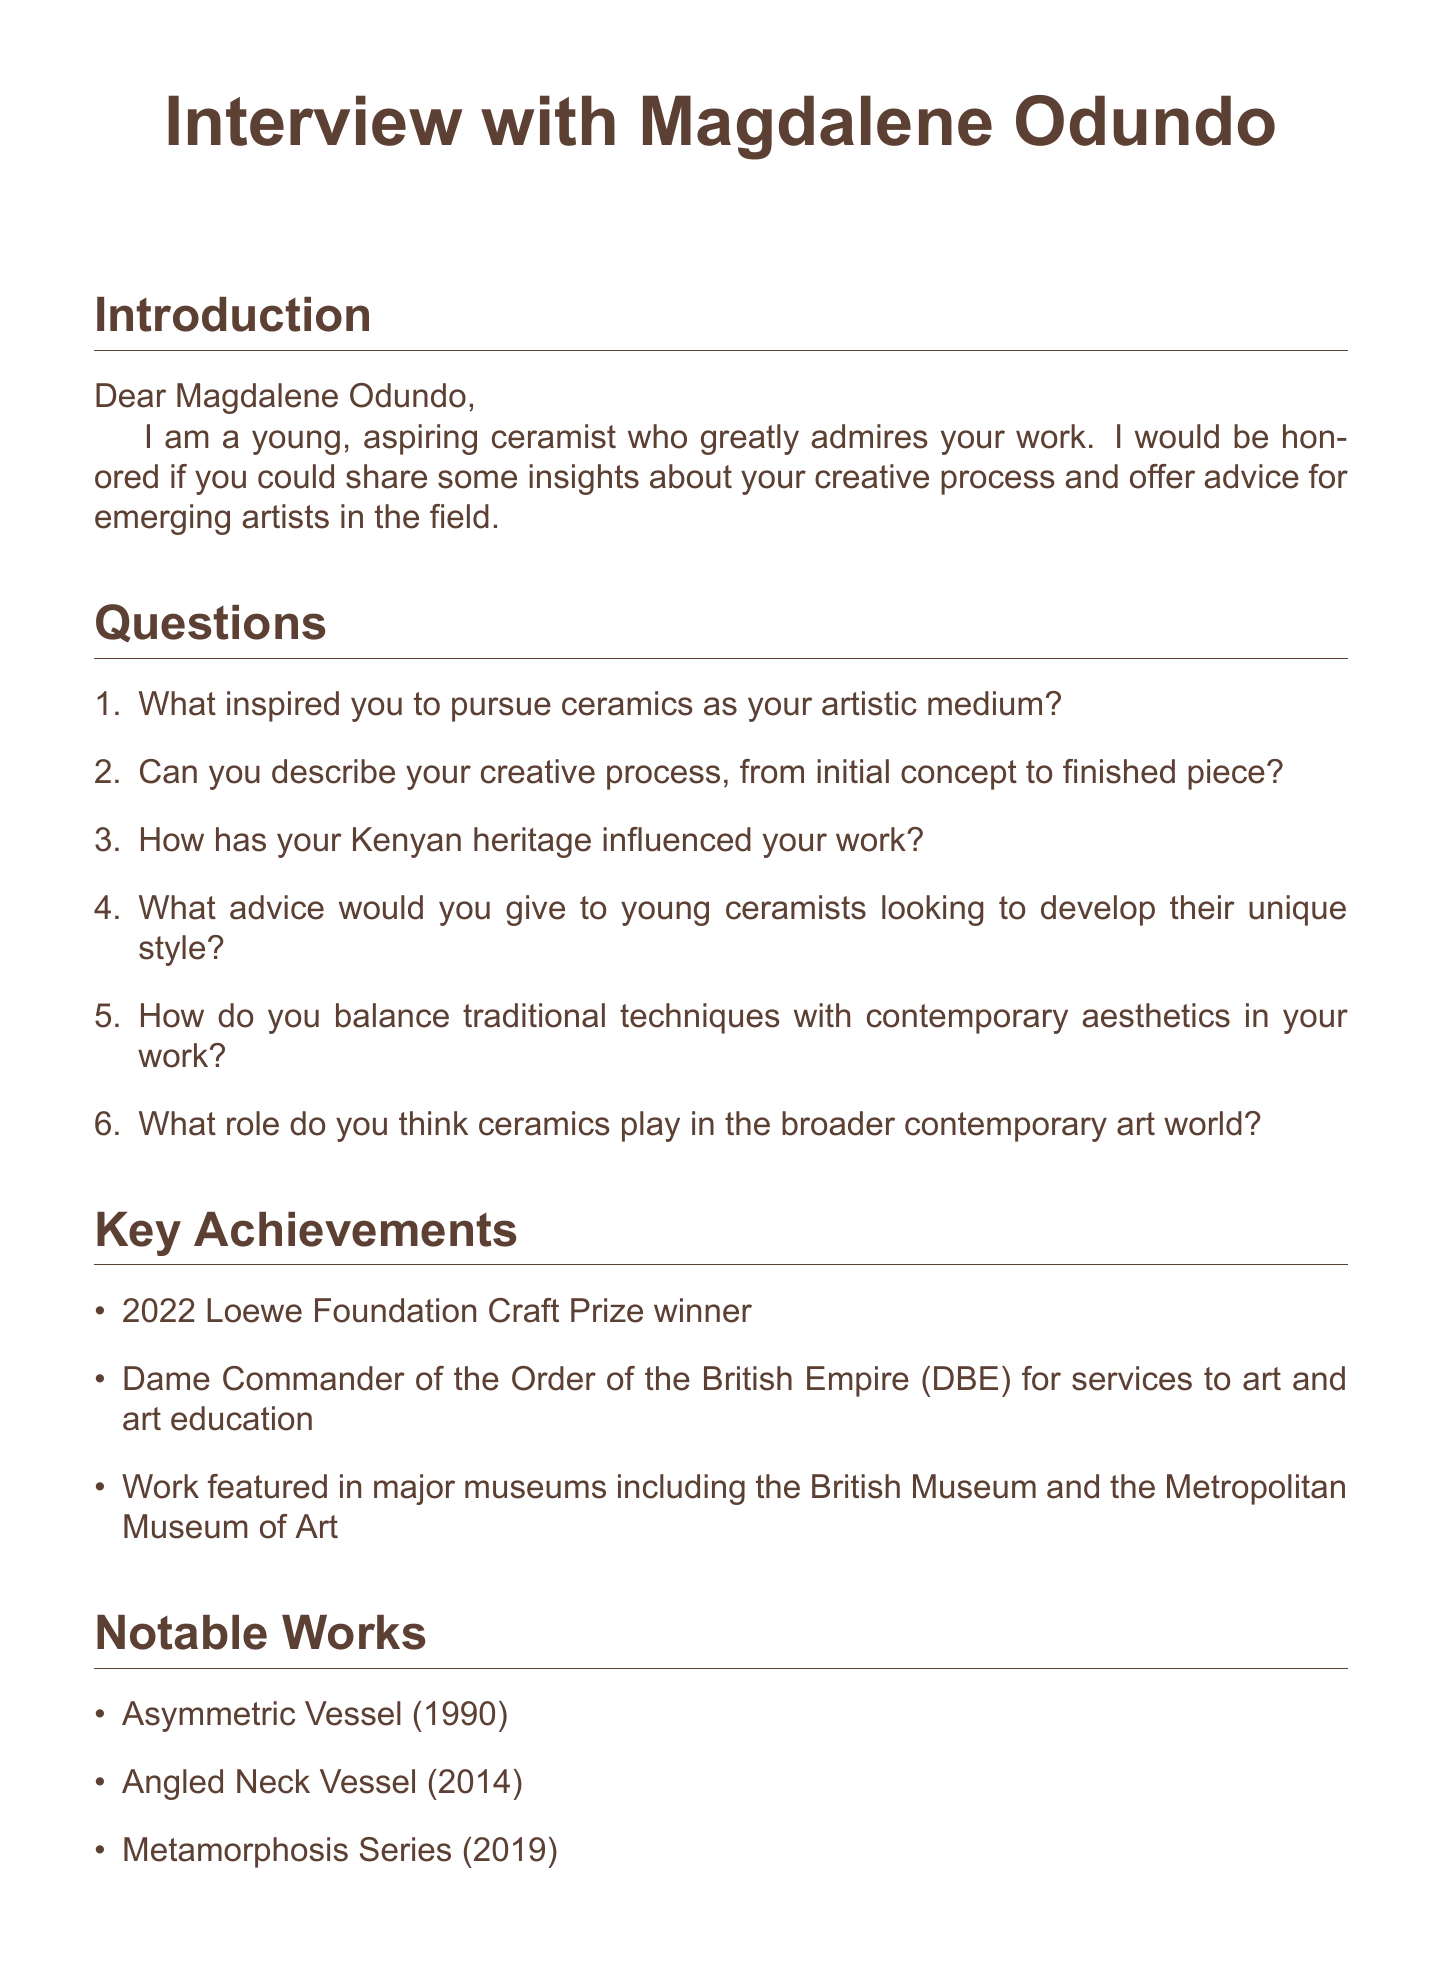What is the email subject? The email subject is found at the beginning of the document.
Answer: Interview with Magdalene Odundo: Insights for Aspiring Ceramists Who is the recipient of the email? The name of the recipient is stated in the introduction section of the document.
Answer: Magdalene Odundo What year did Magdalene Odundo win the Loewe Foundation Craft Prize? The document states that she won this prize in 2022.
Answer: 2022 What is one notable work of Magdalene Odundo mentioned? The document lists several notable works, and one can be selected from that list.
Answer: Asymmetric Vessel (1990) What title was awarded to Magdalene Odundo for her services to art? This title is mentioned under the key achievements section of the email.
Answer: Dame Commander of the Order of the British Empire (DBE) What aspect of her work does the email ask Magdalene Odundo about? The email poses questions about various aspects related to her artistic practice.
Answer: Creative process What is requested from Magdalene Odundo in the introduction? The introduction section specifies what the sender is hoping to receive from Odundo.
Answer: Insights about her creative process and advice How does the email address the recipient? The way the email begins can determine how the recipient is addressed.
Answer: Dear Magdalene Odundo What is the conclusion of the email? The closing remarks summarize the overall message of gratitude and purpose of the email.
Answer: Thank you for your time and consideration 